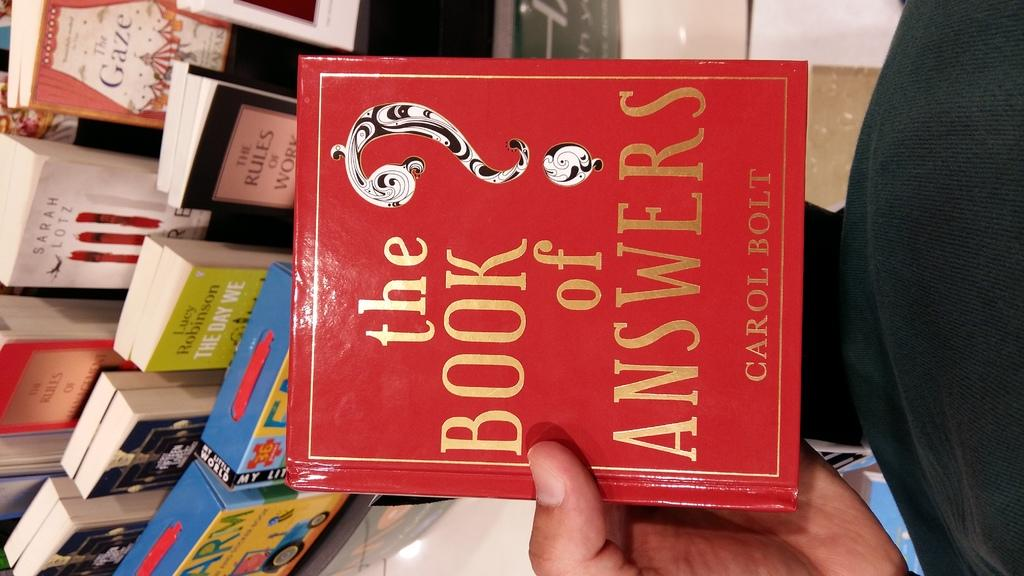<image>
Relay a brief, clear account of the picture shown. A red book entitled the Book of Answers in front of other books. 